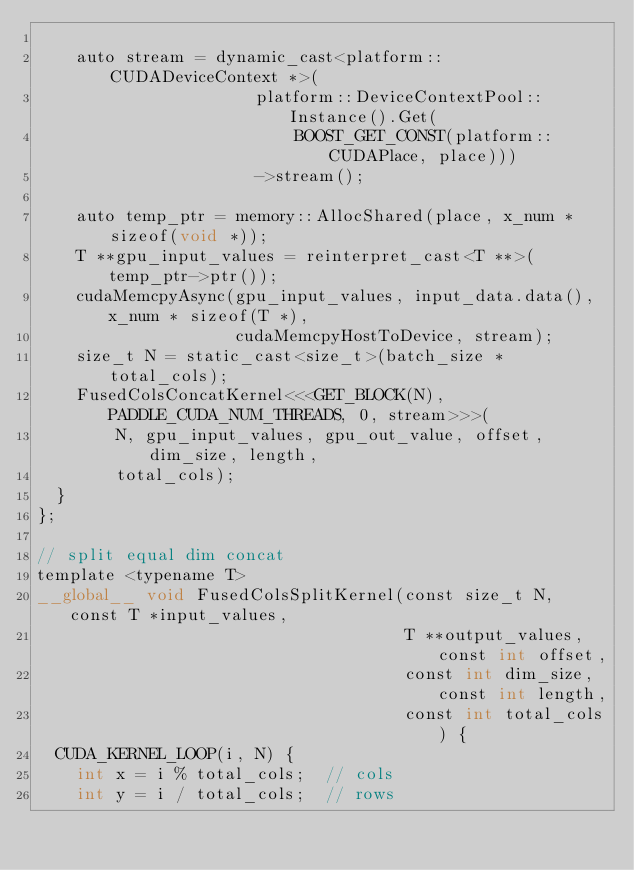Convert code to text. <code><loc_0><loc_0><loc_500><loc_500><_Cuda_>
    auto stream = dynamic_cast<platform::CUDADeviceContext *>(
                      platform::DeviceContextPool::Instance().Get(
                          BOOST_GET_CONST(platform::CUDAPlace, place)))
                      ->stream();

    auto temp_ptr = memory::AllocShared(place, x_num * sizeof(void *));
    T **gpu_input_values = reinterpret_cast<T **>(temp_ptr->ptr());
    cudaMemcpyAsync(gpu_input_values, input_data.data(), x_num * sizeof(T *),
                    cudaMemcpyHostToDevice, stream);
    size_t N = static_cast<size_t>(batch_size * total_cols);
    FusedColsConcatKernel<<<GET_BLOCK(N), PADDLE_CUDA_NUM_THREADS, 0, stream>>>(
        N, gpu_input_values, gpu_out_value, offset, dim_size, length,
        total_cols);
  }
};

// split equal dim concat
template <typename T>
__global__ void FusedColsSplitKernel(const size_t N, const T *input_values,
                                     T **output_values, const int offset,
                                     const int dim_size, const int length,
                                     const int total_cols) {
  CUDA_KERNEL_LOOP(i, N) {
    int x = i % total_cols;  // cols
    int y = i / total_cols;  // rows</code> 